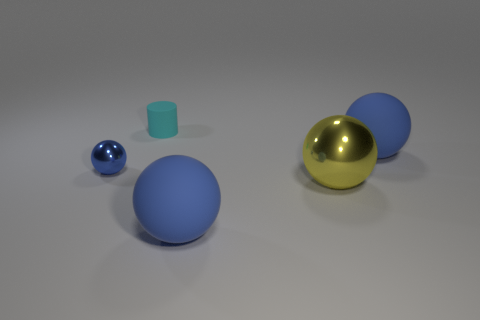Is the material of the blue ball in front of the yellow metal thing the same as the cyan thing?
Your answer should be very brief. Yes. How many objects are things that are left of the small matte cylinder or large yellow shiny objects?
Provide a succinct answer. 2. What is the color of the other ball that is the same material as the large yellow sphere?
Keep it short and to the point. Blue. Is there a blue matte thing of the same size as the cyan cylinder?
Your answer should be compact. No. There is a ball that is to the left of the tiny cyan object; is it the same color as the tiny cylinder?
Provide a short and direct response. No. There is a ball that is both on the right side of the tiny cylinder and to the left of the yellow metal object; what is its color?
Make the answer very short. Blue. There is a blue object that is the same size as the cyan cylinder; what shape is it?
Give a very brief answer. Sphere. Are there any other big objects that have the same shape as the blue metallic thing?
Provide a succinct answer. Yes. Do the metallic sphere in front of the blue metal ball and the tiny matte cylinder have the same size?
Your answer should be very brief. No. What size is the matte object that is right of the small cyan rubber object and behind the tiny blue object?
Provide a short and direct response. Large. 